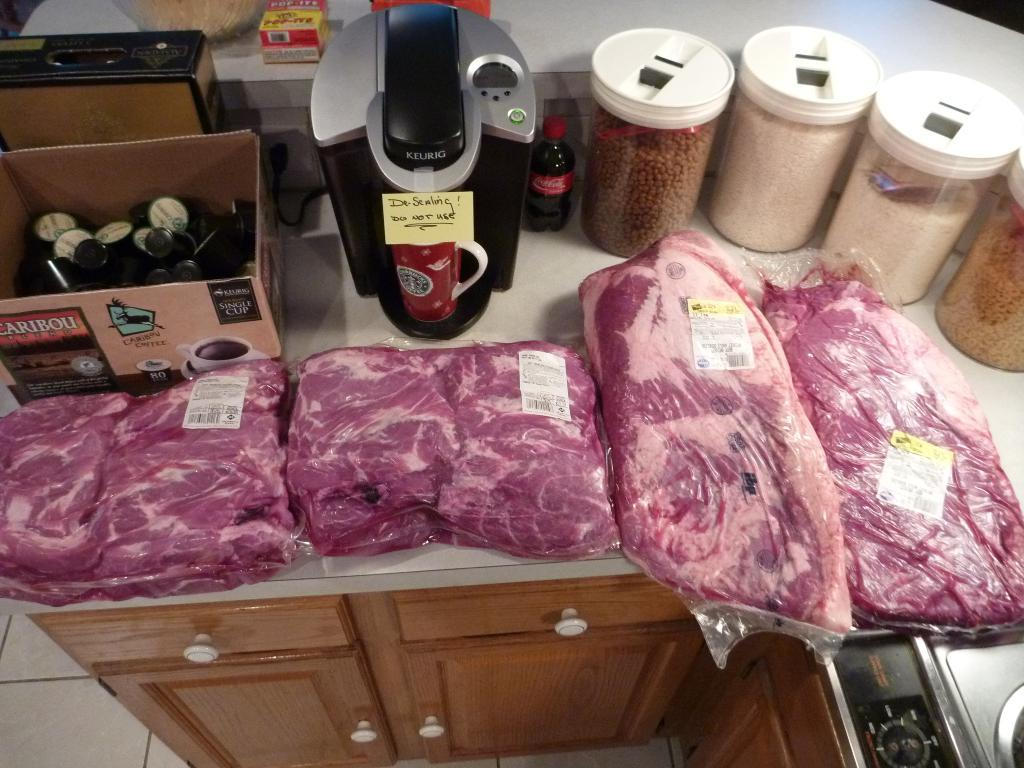<image>
Describe the image concisely. a bunch of meat on the counter and a  Keurig 